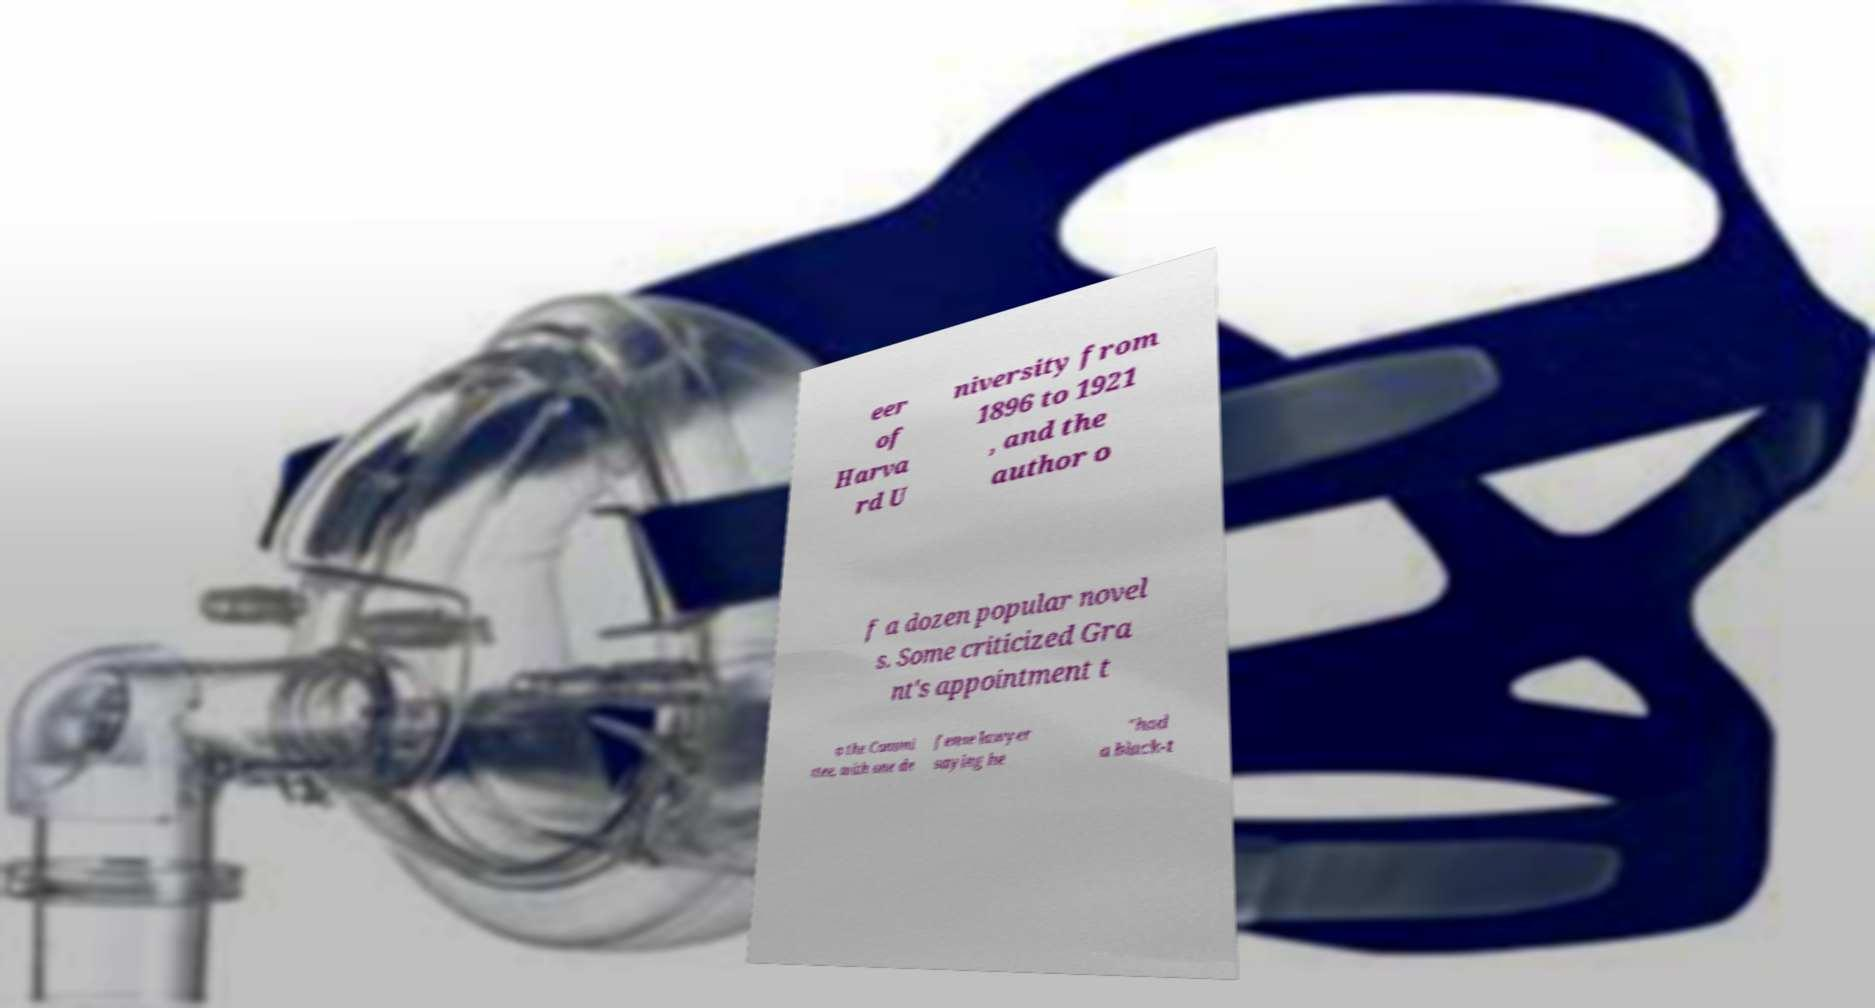Could you extract and type out the text from this image? eer of Harva rd U niversity from 1896 to 1921 , and the author o f a dozen popular novel s. Some criticized Gra nt's appointment t o the Commi ttee, with one de fense lawyer saying he "had a black-t 